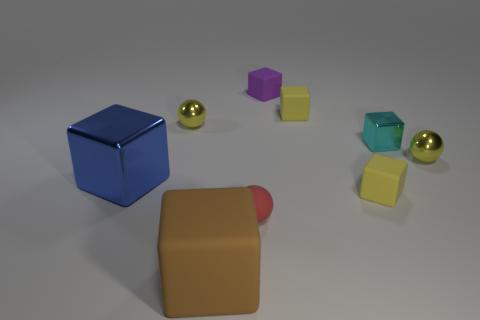Subtract all metallic balls. How many balls are left? 1 Subtract all yellow cubes. How many cubes are left? 4 Add 2 small red blocks. How many small red blocks exist? 2 Subtract 1 red balls. How many objects are left? 8 Subtract all cubes. How many objects are left? 3 Subtract 1 blocks. How many blocks are left? 5 Subtract all purple cubes. Subtract all cyan spheres. How many cubes are left? 5 Subtract all green cubes. How many yellow balls are left? 2 Subtract all tiny spheres. Subtract all large blue shiny blocks. How many objects are left? 5 Add 9 large brown cubes. How many large brown cubes are left? 10 